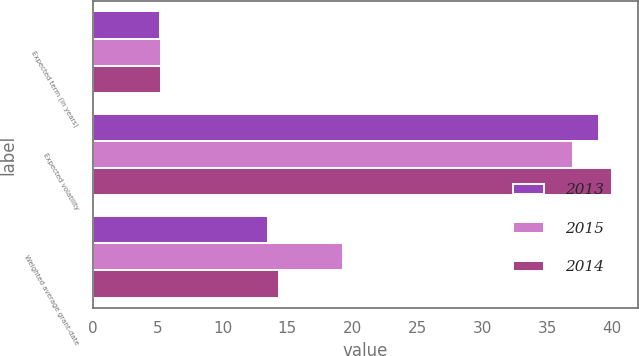Convert chart to OTSL. <chart><loc_0><loc_0><loc_500><loc_500><stacked_bar_chart><ecel><fcel>Expected term (in years)<fcel>Expected volatility<fcel>Weighted average grant-date<nl><fcel>2013<fcel>5.16<fcel>39<fcel>13.47<nl><fcel>2015<fcel>5.23<fcel>37<fcel>19.26<nl><fcel>2014<fcel>5.27<fcel>40<fcel>14.34<nl></chart> 